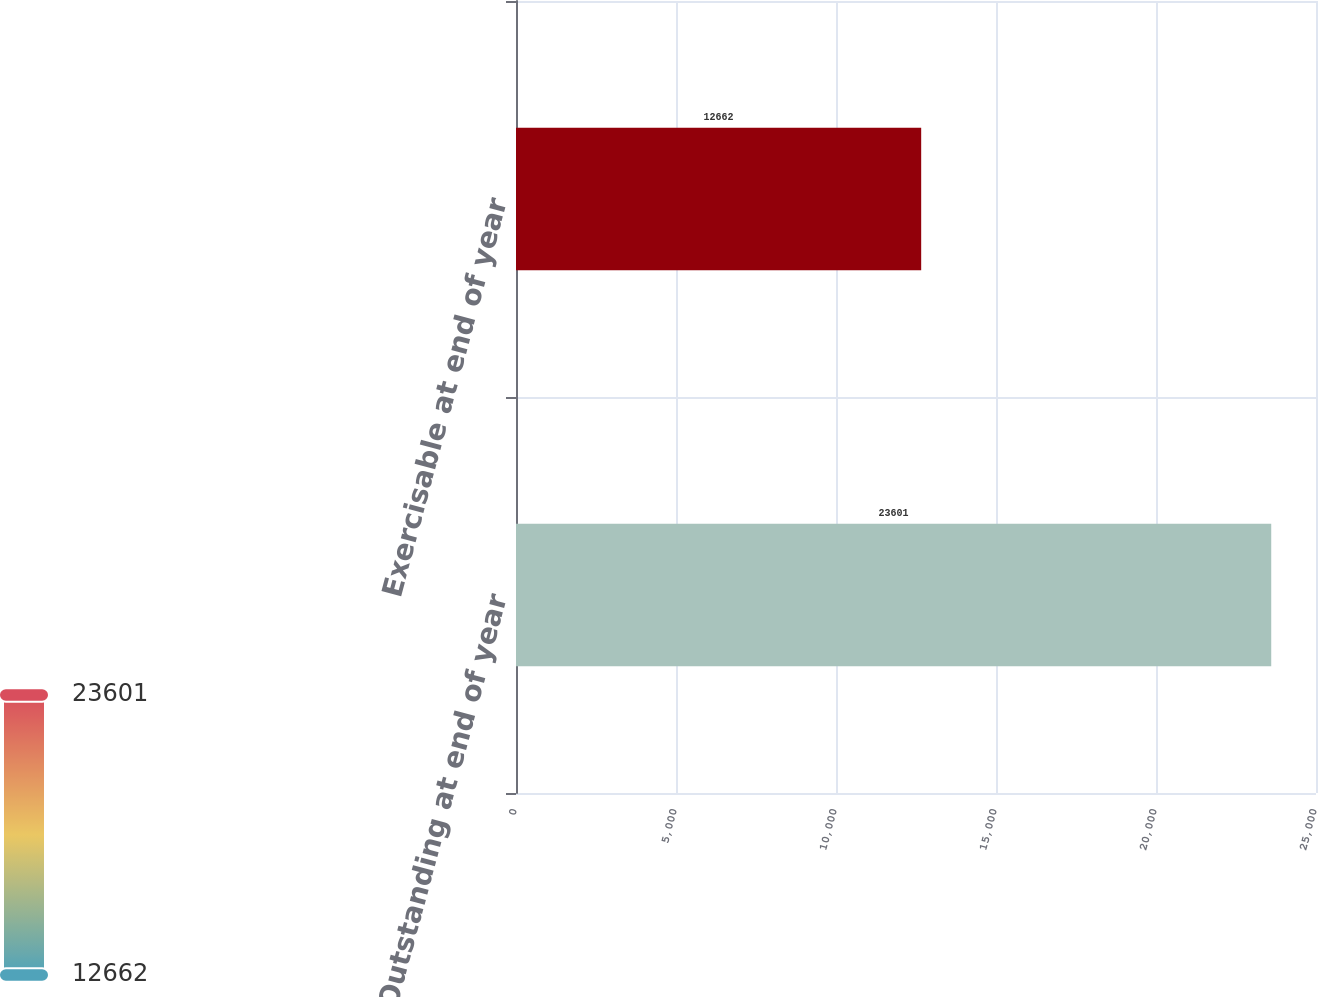<chart> <loc_0><loc_0><loc_500><loc_500><bar_chart><fcel>Outstanding at end of year<fcel>Exercisable at end of year<nl><fcel>23601<fcel>12662<nl></chart> 